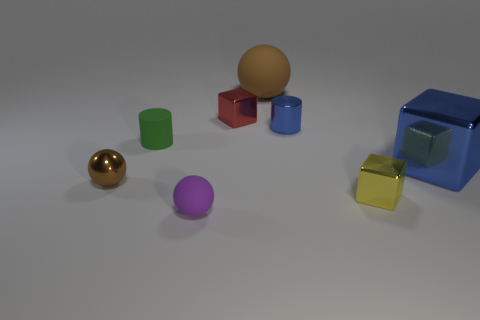There is a big object that is to the left of the blue shiny cube; is it the same shape as the small green rubber object?
Offer a very short reply. No. What size is the blue metal object that is in front of the cylinder to the right of the large thing that is behind the big blue block?
Offer a terse response. Large. What is the size of the metal thing that is the same color as the big block?
Keep it short and to the point. Small. What number of things are either small purple matte cylinders or tiny metal cylinders?
Your answer should be very brief. 1. There is a metal thing that is both left of the large sphere and in front of the large blue object; what shape is it?
Your response must be concise. Sphere. There is a small green rubber thing; is it the same shape as the metallic thing on the left side of the small green rubber cylinder?
Provide a succinct answer. No. There is a small brown sphere; are there any large matte things in front of it?
Your response must be concise. No. There is another sphere that is the same color as the metallic sphere; what is its material?
Offer a very short reply. Rubber. How many spheres are blue objects or purple matte objects?
Your answer should be very brief. 1. Is the big brown matte thing the same shape as the red shiny object?
Offer a terse response. No. 